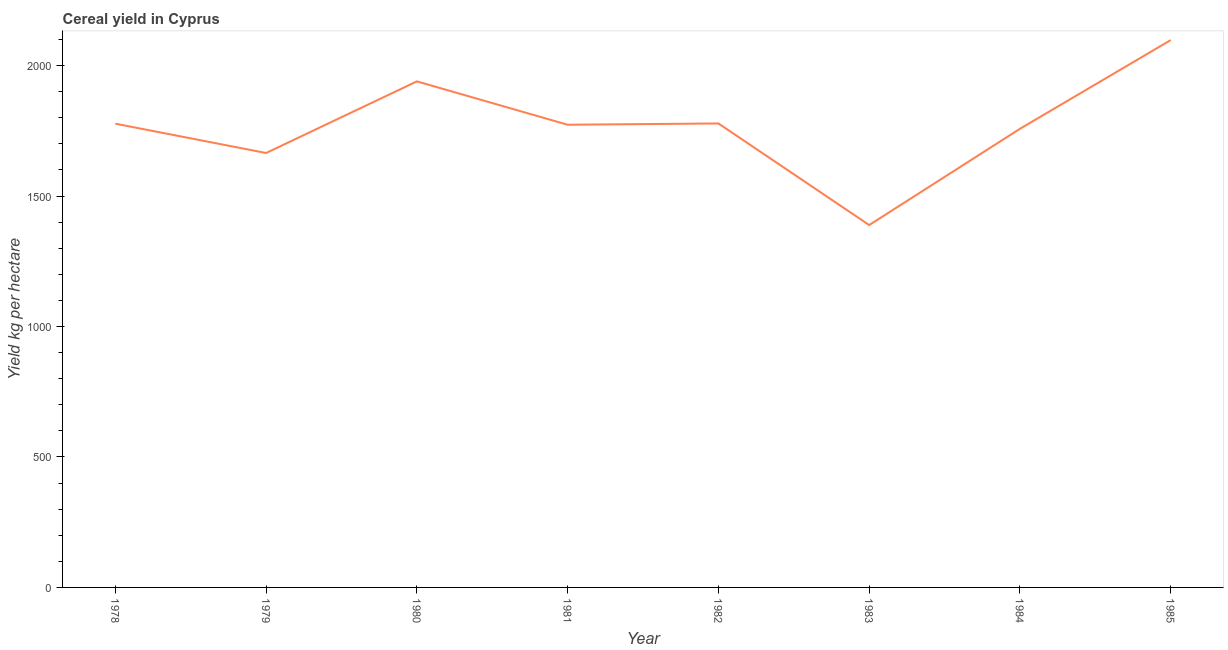What is the cereal yield in 1985?
Your answer should be very brief. 2097.74. Across all years, what is the maximum cereal yield?
Your response must be concise. 2097.74. Across all years, what is the minimum cereal yield?
Offer a terse response. 1388.84. In which year was the cereal yield minimum?
Ensure brevity in your answer.  1983. What is the sum of the cereal yield?
Ensure brevity in your answer.  1.42e+04. What is the difference between the cereal yield in 1981 and 1983?
Provide a short and direct response. 384.43. What is the average cereal yield per year?
Your response must be concise. 1772.19. What is the median cereal yield?
Give a very brief answer. 1775.29. In how many years, is the cereal yield greater than 800 kg per hectare?
Provide a succinct answer. 8. What is the ratio of the cereal yield in 1979 to that in 1981?
Your answer should be very brief. 0.94. Is the cereal yield in 1979 less than that in 1983?
Your response must be concise. No. Is the difference between the cereal yield in 1980 and 1985 greater than the difference between any two years?
Keep it short and to the point. No. What is the difference between the highest and the second highest cereal yield?
Your response must be concise. 158.32. What is the difference between the highest and the lowest cereal yield?
Provide a short and direct response. 708.9. How many lines are there?
Your response must be concise. 1. What is the difference between two consecutive major ticks on the Y-axis?
Make the answer very short. 500. Does the graph contain any zero values?
Ensure brevity in your answer.  No. Does the graph contain grids?
Ensure brevity in your answer.  No. What is the title of the graph?
Provide a short and direct response. Cereal yield in Cyprus. What is the label or title of the X-axis?
Offer a terse response. Year. What is the label or title of the Y-axis?
Provide a succinct answer. Yield kg per hectare. What is the Yield kg per hectare of 1978?
Your response must be concise. 1777.31. What is the Yield kg per hectare in 1979?
Your answer should be compact. 1664.98. What is the Yield kg per hectare in 1980?
Offer a very short reply. 1939.43. What is the Yield kg per hectare of 1981?
Your answer should be very brief. 1773.27. What is the Yield kg per hectare in 1982?
Make the answer very short. 1778.2. What is the Yield kg per hectare in 1983?
Keep it short and to the point. 1388.84. What is the Yield kg per hectare in 1984?
Keep it short and to the point. 1757.73. What is the Yield kg per hectare of 1985?
Make the answer very short. 2097.74. What is the difference between the Yield kg per hectare in 1978 and 1979?
Give a very brief answer. 112.33. What is the difference between the Yield kg per hectare in 1978 and 1980?
Give a very brief answer. -162.11. What is the difference between the Yield kg per hectare in 1978 and 1981?
Make the answer very short. 4.04. What is the difference between the Yield kg per hectare in 1978 and 1982?
Your answer should be very brief. -0.89. What is the difference between the Yield kg per hectare in 1978 and 1983?
Provide a short and direct response. 388.47. What is the difference between the Yield kg per hectare in 1978 and 1984?
Provide a short and direct response. 19.58. What is the difference between the Yield kg per hectare in 1978 and 1985?
Your answer should be very brief. -320.43. What is the difference between the Yield kg per hectare in 1979 and 1980?
Keep it short and to the point. -274.45. What is the difference between the Yield kg per hectare in 1979 and 1981?
Provide a short and direct response. -108.29. What is the difference between the Yield kg per hectare in 1979 and 1982?
Offer a very short reply. -113.22. What is the difference between the Yield kg per hectare in 1979 and 1983?
Your answer should be compact. 276.14. What is the difference between the Yield kg per hectare in 1979 and 1984?
Offer a terse response. -92.75. What is the difference between the Yield kg per hectare in 1979 and 1985?
Your answer should be very brief. -432.77. What is the difference between the Yield kg per hectare in 1980 and 1981?
Keep it short and to the point. 166.16. What is the difference between the Yield kg per hectare in 1980 and 1982?
Your answer should be very brief. 161.23. What is the difference between the Yield kg per hectare in 1980 and 1983?
Offer a terse response. 550.59. What is the difference between the Yield kg per hectare in 1980 and 1984?
Give a very brief answer. 181.69. What is the difference between the Yield kg per hectare in 1980 and 1985?
Make the answer very short. -158.32. What is the difference between the Yield kg per hectare in 1981 and 1982?
Your answer should be very brief. -4.93. What is the difference between the Yield kg per hectare in 1981 and 1983?
Your response must be concise. 384.43. What is the difference between the Yield kg per hectare in 1981 and 1984?
Keep it short and to the point. 15.54. What is the difference between the Yield kg per hectare in 1981 and 1985?
Ensure brevity in your answer.  -324.48. What is the difference between the Yield kg per hectare in 1982 and 1983?
Keep it short and to the point. 389.36. What is the difference between the Yield kg per hectare in 1982 and 1984?
Offer a terse response. 20.47. What is the difference between the Yield kg per hectare in 1982 and 1985?
Make the answer very short. -319.55. What is the difference between the Yield kg per hectare in 1983 and 1984?
Your answer should be very brief. -368.89. What is the difference between the Yield kg per hectare in 1983 and 1985?
Provide a succinct answer. -708.9. What is the difference between the Yield kg per hectare in 1984 and 1985?
Offer a very short reply. -340.01. What is the ratio of the Yield kg per hectare in 1978 to that in 1979?
Your response must be concise. 1.07. What is the ratio of the Yield kg per hectare in 1978 to that in 1980?
Ensure brevity in your answer.  0.92. What is the ratio of the Yield kg per hectare in 1978 to that in 1981?
Make the answer very short. 1. What is the ratio of the Yield kg per hectare in 1978 to that in 1983?
Provide a short and direct response. 1.28. What is the ratio of the Yield kg per hectare in 1978 to that in 1984?
Your answer should be compact. 1.01. What is the ratio of the Yield kg per hectare in 1978 to that in 1985?
Provide a short and direct response. 0.85. What is the ratio of the Yield kg per hectare in 1979 to that in 1980?
Keep it short and to the point. 0.86. What is the ratio of the Yield kg per hectare in 1979 to that in 1981?
Provide a succinct answer. 0.94. What is the ratio of the Yield kg per hectare in 1979 to that in 1982?
Ensure brevity in your answer.  0.94. What is the ratio of the Yield kg per hectare in 1979 to that in 1983?
Your answer should be compact. 1.2. What is the ratio of the Yield kg per hectare in 1979 to that in 1984?
Provide a succinct answer. 0.95. What is the ratio of the Yield kg per hectare in 1979 to that in 1985?
Provide a short and direct response. 0.79. What is the ratio of the Yield kg per hectare in 1980 to that in 1981?
Your answer should be very brief. 1.09. What is the ratio of the Yield kg per hectare in 1980 to that in 1982?
Offer a very short reply. 1.09. What is the ratio of the Yield kg per hectare in 1980 to that in 1983?
Your answer should be compact. 1.4. What is the ratio of the Yield kg per hectare in 1980 to that in 1984?
Keep it short and to the point. 1.1. What is the ratio of the Yield kg per hectare in 1980 to that in 1985?
Your answer should be compact. 0.93. What is the ratio of the Yield kg per hectare in 1981 to that in 1982?
Give a very brief answer. 1. What is the ratio of the Yield kg per hectare in 1981 to that in 1983?
Offer a terse response. 1.28. What is the ratio of the Yield kg per hectare in 1981 to that in 1984?
Make the answer very short. 1.01. What is the ratio of the Yield kg per hectare in 1981 to that in 1985?
Offer a terse response. 0.84. What is the ratio of the Yield kg per hectare in 1982 to that in 1983?
Give a very brief answer. 1.28. What is the ratio of the Yield kg per hectare in 1982 to that in 1984?
Keep it short and to the point. 1.01. What is the ratio of the Yield kg per hectare in 1982 to that in 1985?
Provide a short and direct response. 0.85. What is the ratio of the Yield kg per hectare in 1983 to that in 1984?
Make the answer very short. 0.79. What is the ratio of the Yield kg per hectare in 1983 to that in 1985?
Give a very brief answer. 0.66. What is the ratio of the Yield kg per hectare in 1984 to that in 1985?
Your response must be concise. 0.84. 